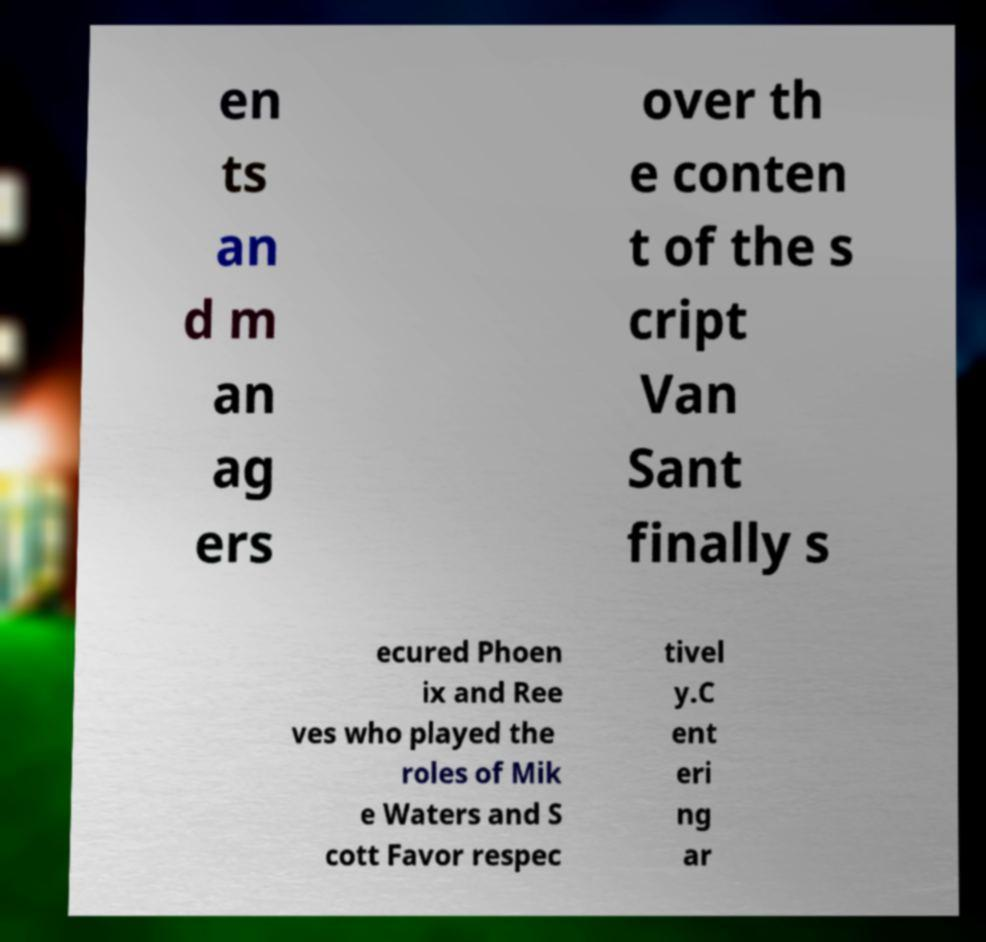For documentation purposes, I need the text within this image transcribed. Could you provide that? en ts an d m an ag ers over th e conten t of the s cript Van Sant finally s ecured Phoen ix and Ree ves who played the roles of Mik e Waters and S cott Favor respec tivel y.C ent eri ng ar 